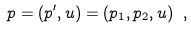<formula> <loc_0><loc_0><loc_500><loc_500>p = ( p ^ { \prime } , u ) = ( p _ { 1 } , p _ { 2 } , u ) \ ,</formula> 